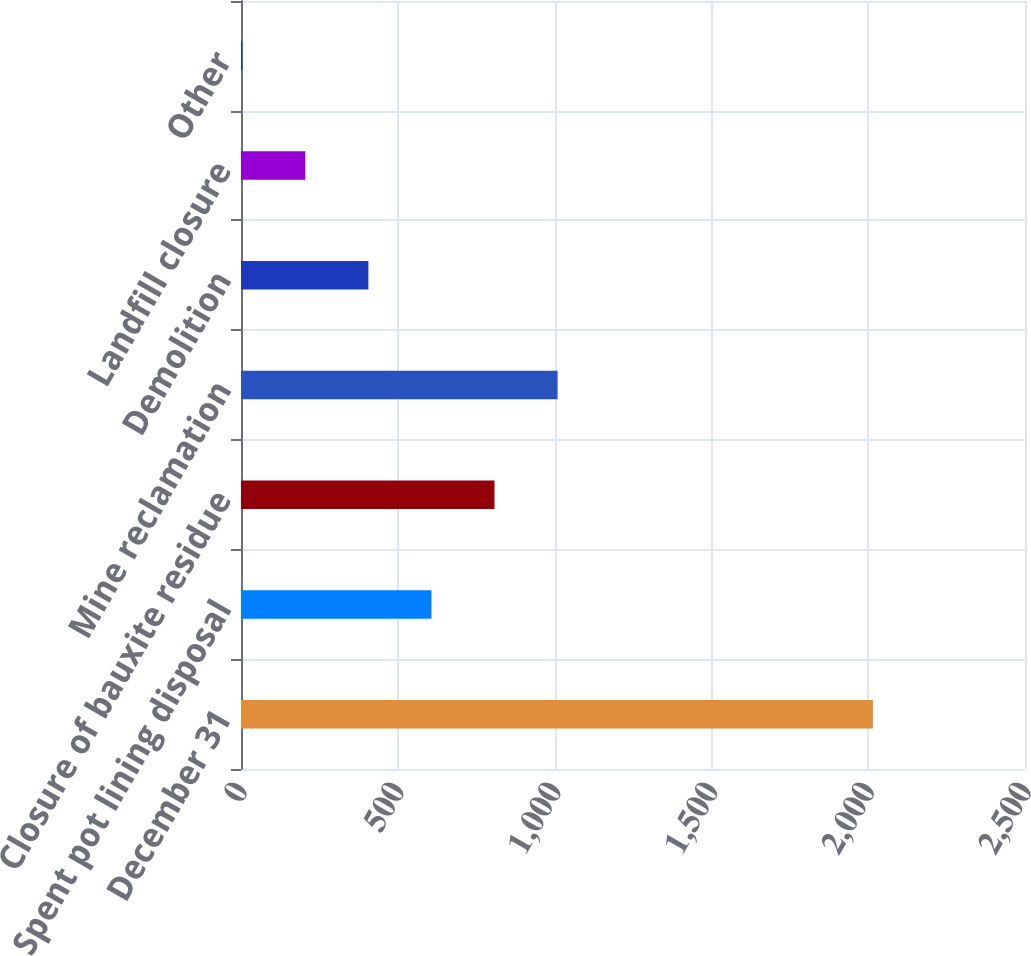<chart> <loc_0><loc_0><loc_500><loc_500><bar_chart><fcel>December 31<fcel>Spent pot lining disposal<fcel>Closure of bauxite residue<fcel>Mine reclamation<fcel>Demolition<fcel>Landfill closure<fcel>Other<nl><fcel>2015<fcel>607.3<fcel>808.4<fcel>1009.5<fcel>406.2<fcel>205.1<fcel>4<nl></chart> 